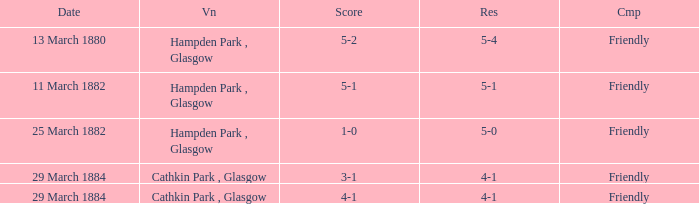Which item resulted in a score of 4-1? 3-1, 4-1. 